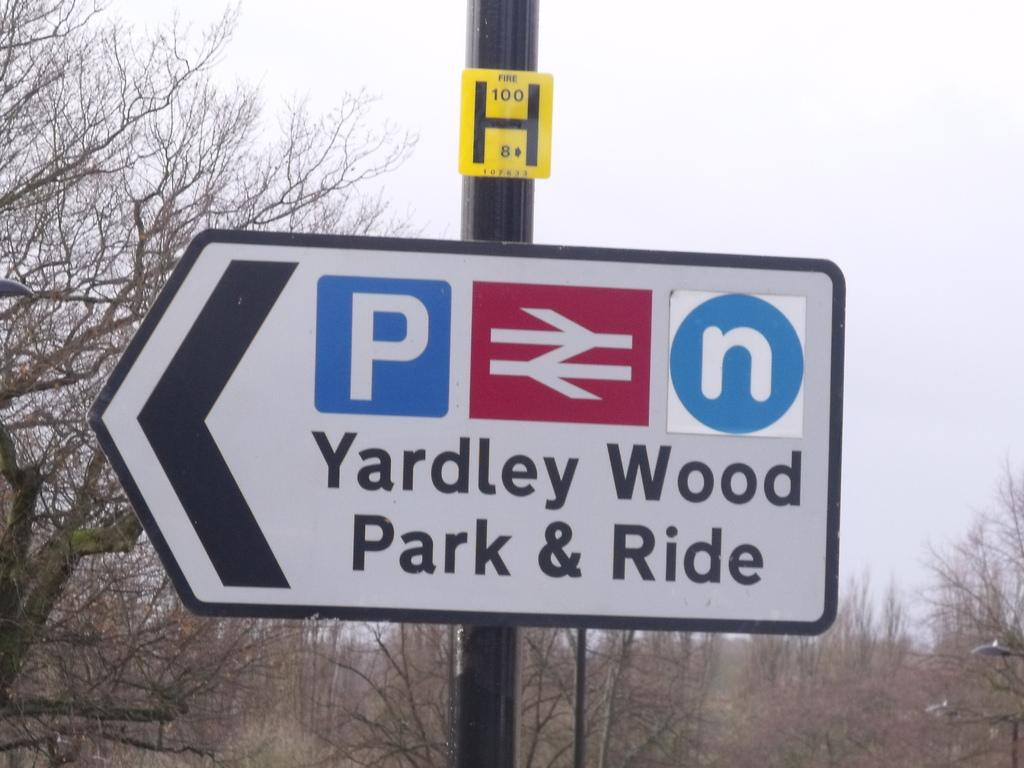<image>
Summarize the visual content of the image. A sign pointing to Yardley Wood Park and Ride. 